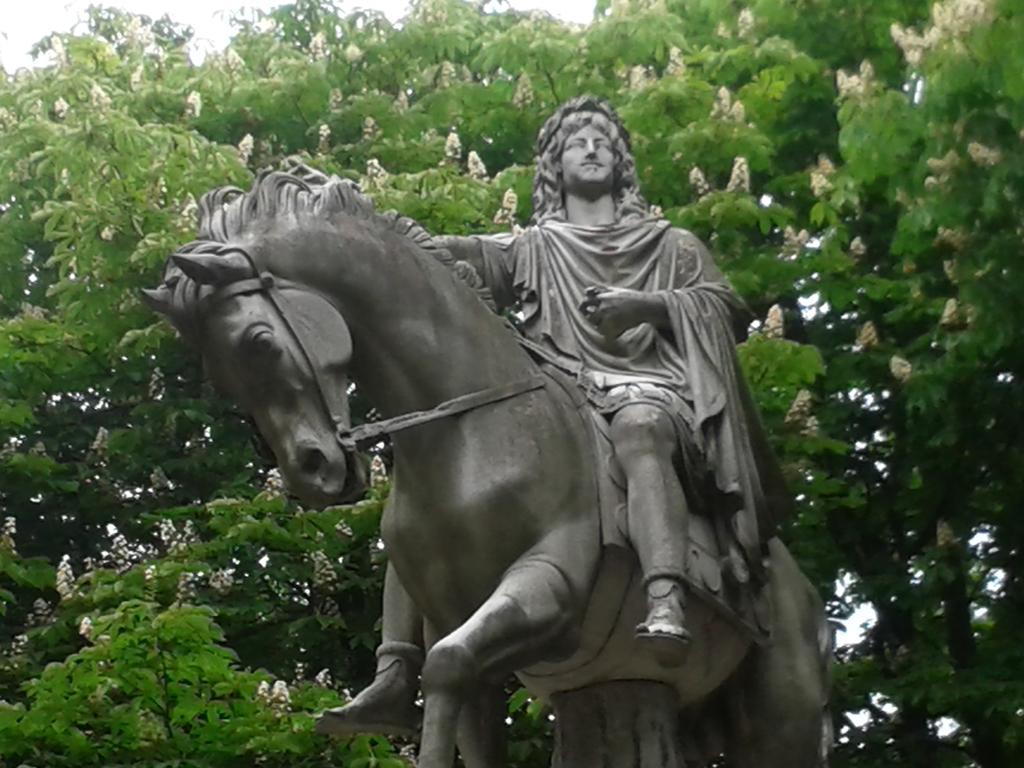Can you describe this image briefly? In this picture there is a statue of a person sitting on the horse. At the back there is a tree and there are flowers on the tree. At the top there is sky. 